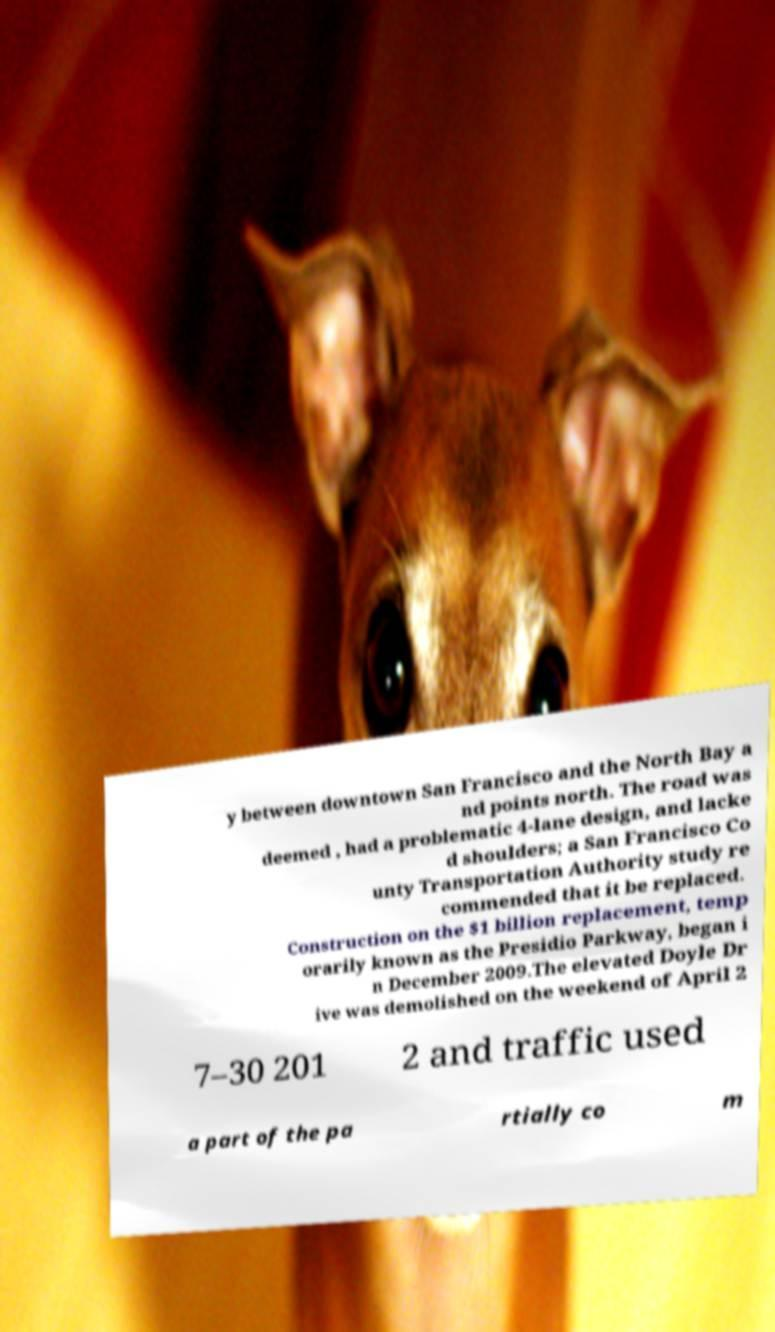For documentation purposes, I need the text within this image transcribed. Could you provide that? y between downtown San Francisco and the North Bay a nd points north. The road was deemed , had a problematic 4-lane design, and lacke d shoulders; a San Francisco Co unty Transportation Authority study re commended that it be replaced. Construction on the $1 billion replacement, temp orarily known as the Presidio Parkway, began i n December 2009.The elevated Doyle Dr ive was demolished on the weekend of April 2 7–30 201 2 and traffic used a part of the pa rtially co m 